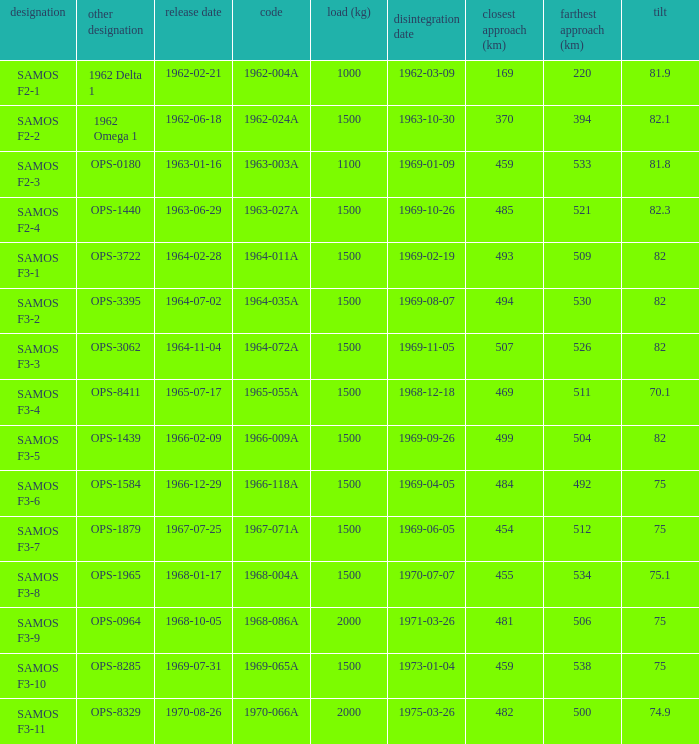What is the maximum apogee for samos f3-3? 526.0. Parse the table in full. {'header': ['designation', 'other designation', 'release date', 'code', 'load (kg)', 'disintegration date', 'closest approach (km)', 'farthest approach (km)', 'tilt'], 'rows': [['SAMOS F2-1', '1962 Delta 1', '1962-02-21', '1962-004A', '1000', '1962-03-09', '169', '220', '81.9'], ['SAMOS F2-2', '1962 Omega 1', '1962-06-18', '1962-024A', '1500', '1963-10-30', '370', '394', '82.1'], ['SAMOS F2-3', 'OPS-0180', '1963-01-16', '1963-003A', '1100', '1969-01-09', '459', '533', '81.8'], ['SAMOS F2-4', 'OPS-1440', '1963-06-29', '1963-027A', '1500', '1969-10-26', '485', '521', '82.3'], ['SAMOS F3-1', 'OPS-3722', '1964-02-28', '1964-011A', '1500', '1969-02-19', '493', '509', '82'], ['SAMOS F3-2', 'OPS-3395', '1964-07-02', '1964-035A', '1500', '1969-08-07', '494', '530', '82'], ['SAMOS F3-3', 'OPS-3062', '1964-11-04', '1964-072A', '1500', '1969-11-05', '507', '526', '82'], ['SAMOS F3-4', 'OPS-8411', '1965-07-17', '1965-055A', '1500', '1968-12-18', '469', '511', '70.1'], ['SAMOS F3-5', 'OPS-1439', '1966-02-09', '1966-009A', '1500', '1969-09-26', '499', '504', '82'], ['SAMOS F3-6', 'OPS-1584', '1966-12-29', '1966-118A', '1500', '1969-04-05', '484', '492', '75'], ['SAMOS F3-7', 'OPS-1879', '1967-07-25', '1967-071A', '1500', '1969-06-05', '454', '512', '75'], ['SAMOS F3-8', 'OPS-1965', '1968-01-17', '1968-004A', '1500', '1970-07-07', '455', '534', '75.1'], ['SAMOS F3-9', 'OPS-0964', '1968-10-05', '1968-086A', '2000', '1971-03-26', '481', '506', '75'], ['SAMOS F3-10', 'OPS-8285', '1969-07-31', '1969-065A', '1500', '1973-01-04', '459', '538', '75'], ['SAMOS F3-11', 'OPS-8329', '1970-08-26', '1970-066A', '2000', '1975-03-26', '482', '500', '74.9']]} 